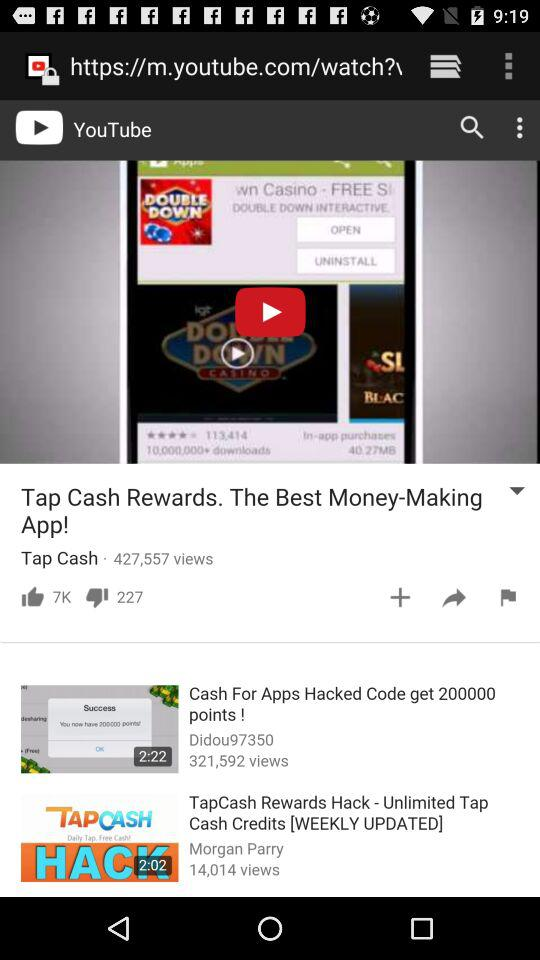How many views does the second video have?
Answer the question using a single word or phrase. 321,592 